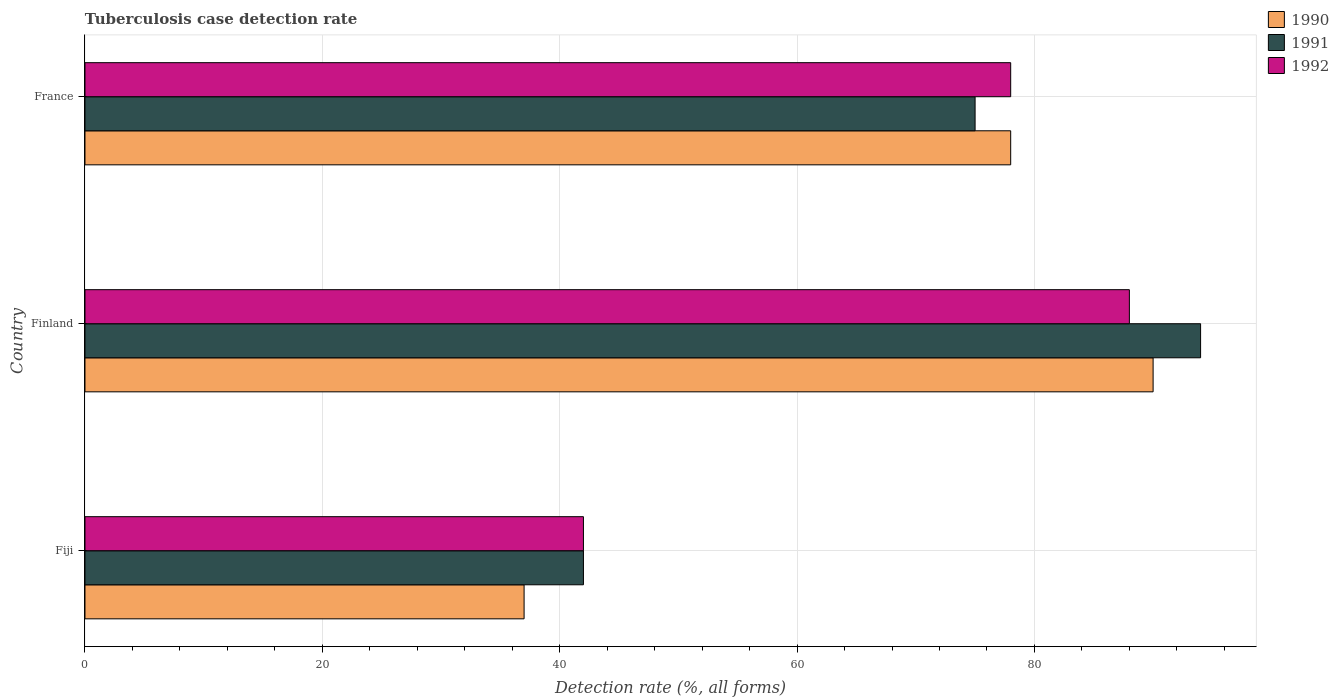How many different coloured bars are there?
Provide a short and direct response. 3. Are the number of bars per tick equal to the number of legend labels?
Provide a short and direct response. Yes. Are the number of bars on each tick of the Y-axis equal?
Provide a short and direct response. Yes. How many bars are there on the 2nd tick from the bottom?
Keep it short and to the point. 3. What is the label of the 1st group of bars from the top?
Offer a very short reply. France. In which country was the tuberculosis case detection rate in in 1990 minimum?
Your response must be concise. Fiji. What is the total tuberculosis case detection rate in in 1990 in the graph?
Your answer should be compact. 205. What is the difference between the tuberculosis case detection rate in in 1991 in Fiji and the tuberculosis case detection rate in in 1990 in France?
Your answer should be very brief. -36. What is the average tuberculosis case detection rate in in 1991 per country?
Provide a short and direct response. 70.33. What is the difference between the tuberculosis case detection rate in in 1991 and tuberculosis case detection rate in in 1992 in Finland?
Offer a terse response. 6. In how many countries, is the tuberculosis case detection rate in in 1991 greater than 28 %?
Your answer should be compact. 3. What is the ratio of the tuberculosis case detection rate in in 1991 in Fiji to that in France?
Provide a short and direct response. 0.56. Is the tuberculosis case detection rate in in 1991 in Fiji less than that in Finland?
Ensure brevity in your answer.  Yes. Is the sum of the tuberculosis case detection rate in in 1992 in Fiji and France greater than the maximum tuberculosis case detection rate in in 1990 across all countries?
Your answer should be very brief. Yes. What does the 2nd bar from the top in France represents?
Provide a succinct answer. 1991. What does the 2nd bar from the bottom in Finland represents?
Provide a short and direct response. 1991. Is it the case that in every country, the sum of the tuberculosis case detection rate in in 1992 and tuberculosis case detection rate in in 1991 is greater than the tuberculosis case detection rate in in 1990?
Ensure brevity in your answer.  Yes. How many bars are there?
Keep it short and to the point. 9. How many countries are there in the graph?
Offer a terse response. 3. What is the difference between two consecutive major ticks on the X-axis?
Provide a short and direct response. 20. Are the values on the major ticks of X-axis written in scientific E-notation?
Give a very brief answer. No. How many legend labels are there?
Offer a terse response. 3. What is the title of the graph?
Give a very brief answer. Tuberculosis case detection rate. Does "1990" appear as one of the legend labels in the graph?
Your response must be concise. Yes. What is the label or title of the X-axis?
Offer a terse response. Detection rate (%, all forms). What is the label or title of the Y-axis?
Your response must be concise. Country. What is the Detection rate (%, all forms) in 1990 in Fiji?
Ensure brevity in your answer.  37. What is the Detection rate (%, all forms) in 1991 in Fiji?
Offer a very short reply. 42. What is the Detection rate (%, all forms) of 1990 in Finland?
Your answer should be compact. 90. What is the Detection rate (%, all forms) of 1991 in Finland?
Make the answer very short. 94. What is the Detection rate (%, all forms) in 1990 in France?
Offer a very short reply. 78. What is the Detection rate (%, all forms) of 1992 in France?
Keep it short and to the point. 78. Across all countries, what is the maximum Detection rate (%, all forms) of 1990?
Keep it short and to the point. 90. Across all countries, what is the maximum Detection rate (%, all forms) in 1991?
Give a very brief answer. 94. Across all countries, what is the minimum Detection rate (%, all forms) in 1991?
Provide a short and direct response. 42. Across all countries, what is the minimum Detection rate (%, all forms) in 1992?
Ensure brevity in your answer.  42. What is the total Detection rate (%, all forms) of 1990 in the graph?
Keep it short and to the point. 205. What is the total Detection rate (%, all forms) of 1991 in the graph?
Provide a short and direct response. 211. What is the total Detection rate (%, all forms) of 1992 in the graph?
Your answer should be compact. 208. What is the difference between the Detection rate (%, all forms) in 1990 in Fiji and that in Finland?
Offer a very short reply. -53. What is the difference between the Detection rate (%, all forms) of 1991 in Fiji and that in Finland?
Make the answer very short. -52. What is the difference between the Detection rate (%, all forms) in 1992 in Fiji and that in Finland?
Keep it short and to the point. -46. What is the difference between the Detection rate (%, all forms) in 1990 in Fiji and that in France?
Offer a terse response. -41. What is the difference between the Detection rate (%, all forms) of 1991 in Fiji and that in France?
Offer a very short reply. -33. What is the difference between the Detection rate (%, all forms) in 1992 in Fiji and that in France?
Offer a very short reply. -36. What is the difference between the Detection rate (%, all forms) of 1990 in Finland and that in France?
Make the answer very short. 12. What is the difference between the Detection rate (%, all forms) in 1990 in Fiji and the Detection rate (%, all forms) in 1991 in Finland?
Make the answer very short. -57. What is the difference between the Detection rate (%, all forms) in 1990 in Fiji and the Detection rate (%, all forms) in 1992 in Finland?
Ensure brevity in your answer.  -51. What is the difference between the Detection rate (%, all forms) in 1991 in Fiji and the Detection rate (%, all forms) in 1992 in Finland?
Provide a short and direct response. -46. What is the difference between the Detection rate (%, all forms) of 1990 in Fiji and the Detection rate (%, all forms) of 1991 in France?
Your answer should be compact. -38. What is the difference between the Detection rate (%, all forms) in 1990 in Fiji and the Detection rate (%, all forms) in 1992 in France?
Provide a short and direct response. -41. What is the difference between the Detection rate (%, all forms) in 1991 in Fiji and the Detection rate (%, all forms) in 1992 in France?
Your response must be concise. -36. What is the difference between the Detection rate (%, all forms) of 1990 in Finland and the Detection rate (%, all forms) of 1991 in France?
Provide a succinct answer. 15. What is the difference between the Detection rate (%, all forms) in 1990 in Finland and the Detection rate (%, all forms) in 1992 in France?
Your answer should be very brief. 12. What is the difference between the Detection rate (%, all forms) in 1991 in Finland and the Detection rate (%, all forms) in 1992 in France?
Your answer should be very brief. 16. What is the average Detection rate (%, all forms) of 1990 per country?
Offer a very short reply. 68.33. What is the average Detection rate (%, all forms) of 1991 per country?
Offer a very short reply. 70.33. What is the average Detection rate (%, all forms) of 1992 per country?
Ensure brevity in your answer.  69.33. What is the difference between the Detection rate (%, all forms) in 1991 and Detection rate (%, all forms) in 1992 in Fiji?
Offer a terse response. 0. What is the difference between the Detection rate (%, all forms) in 1990 and Detection rate (%, all forms) in 1992 in Finland?
Your response must be concise. 2. What is the difference between the Detection rate (%, all forms) in 1990 and Detection rate (%, all forms) in 1991 in France?
Ensure brevity in your answer.  3. What is the ratio of the Detection rate (%, all forms) of 1990 in Fiji to that in Finland?
Make the answer very short. 0.41. What is the ratio of the Detection rate (%, all forms) of 1991 in Fiji to that in Finland?
Give a very brief answer. 0.45. What is the ratio of the Detection rate (%, all forms) in 1992 in Fiji to that in Finland?
Your answer should be compact. 0.48. What is the ratio of the Detection rate (%, all forms) in 1990 in Fiji to that in France?
Offer a very short reply. 0.47. What is the ratio of the Detection rate (%, all forms) of 1991 in Fiji to that in France?
Ensure brevity in your answer.  0.56. What is the ratio of the Detection rate (%, all forms) in 1992 in Fiji to that in France?
Make the answer very short. 0.54. What is the ratio of the Detection rate (%, all forms) in 1990 in Finland to that in France?
Keep it short and to the point. 1.15. What is the ratio of the Detection rate (%, all forms) in 1991 in Finland to that in France?
Ensure brevity in your answer.  1.25. What is the ratio of the Detection rate (%, all forms) of 1992 in Finland to that in France?
Offer a very short reply. 1.13. What is the difference between the highest and the second highest Detection rate (%, all forms) of 1991?
Offer a very short reply. 19. What is the difference between the highest and the second highest Detection rate (%, all forms) of 1992?
Your response must be concise. 10. What is the difference between the highest and the lowest Detection rate (%, all forms) in 1990?
Offer a very short reply. 53. 